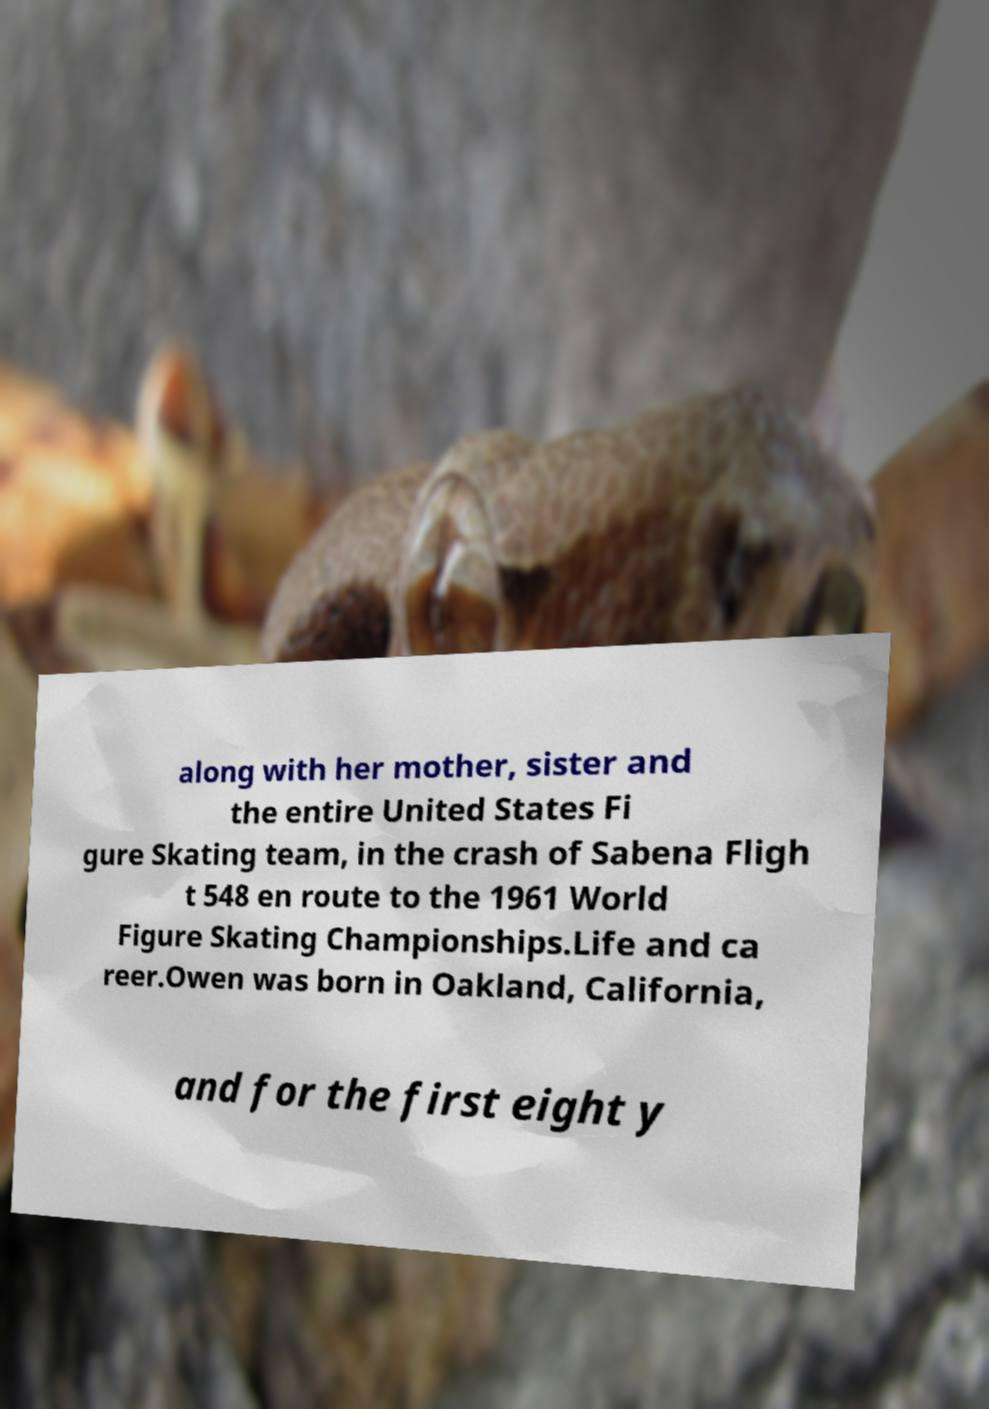I need the written content from this picture converted into text. Can you do that? along with her mother, sister and the entire United States Fi gure Skating team, in the crash of Sabena Fligh t 548 en route to the 1961 World Figure Skating Championships.Life and ca reer.Owen was born in Oakland, California, and for the first eight y 